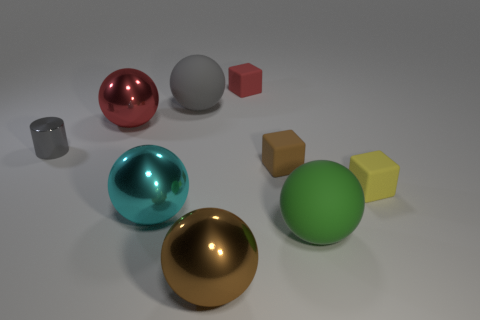Can you guess the purpose of this arrangement of objects? This object arrangement may serve as a demonstration of how different shapes and materials interact with light, possibly for a graphics rendering test or an educational exhibit on geometry and texture. How can we tell the difference between the materials? The differences can be discerned by observing how light reflects and refracts on each object. For instance, metals have high reflectivity with clear specular highlights, while matte materials absorb more light and have diffused reflections. 